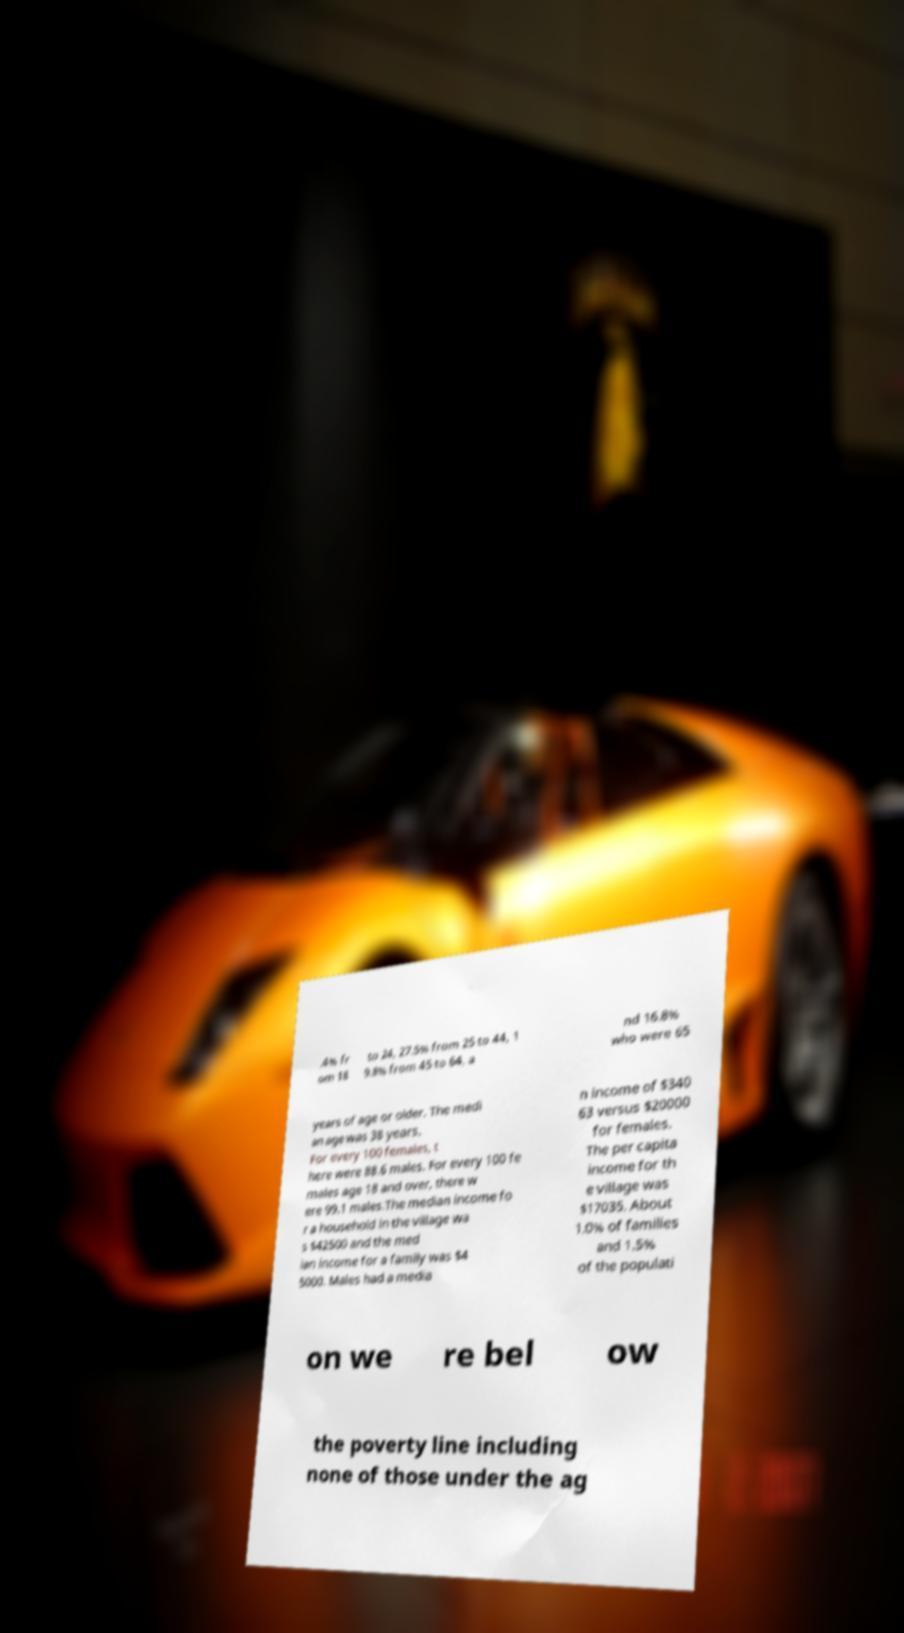Please identify and transcribe the text found in this image. .4% fr om 18 to 24, 27.5% from 25 to 44, 1 9.8% from 45 to 64, a nd 16.8% who were 65 years of age or older. The medi an age was 38 years. For every 100 females, t here were 88.6 males. For every 100 fe males age 18 and over, there w ere 99.1 males.The median income fo r a household in the village wa s $42500 and the med ian income for a family was $4 5000. Males had a media n income of $340 63 versus $20000 for females. The per capita income for th e village was $17035. About 1.0% of families and 1.5% of the populati on we re bel ow the poverty line including none of those under the ag 